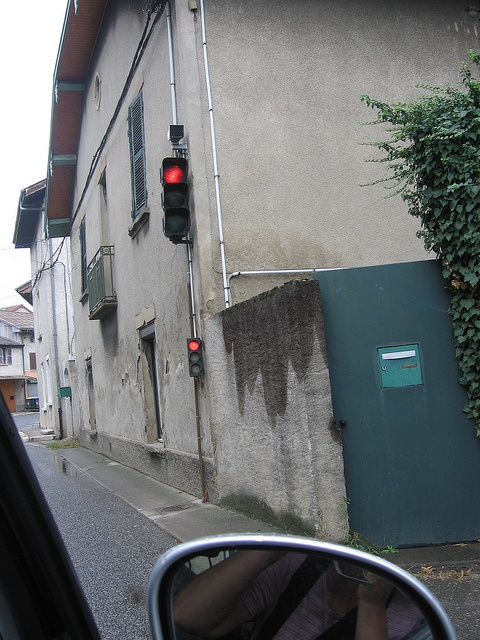Describe the objects in this image and their specific colors. I can see car in white, black, and gray tones, traffic light in white, black, darkgray, gray, and brown tones, and traffic light in white, black, gray, and darkblue tones in this image. 